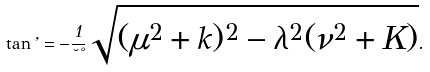<formula> <loc_0><loc_0><loc_500><loc_500>\tan \varphi = - \frac { 1 } { \lambda \nu } \sqrt { ( \mu ^ { 2 } + k ) ^ { 2 } - \lambda ^ { 2 } ( \nu ^ { 2 } + K ) } .</formula> 